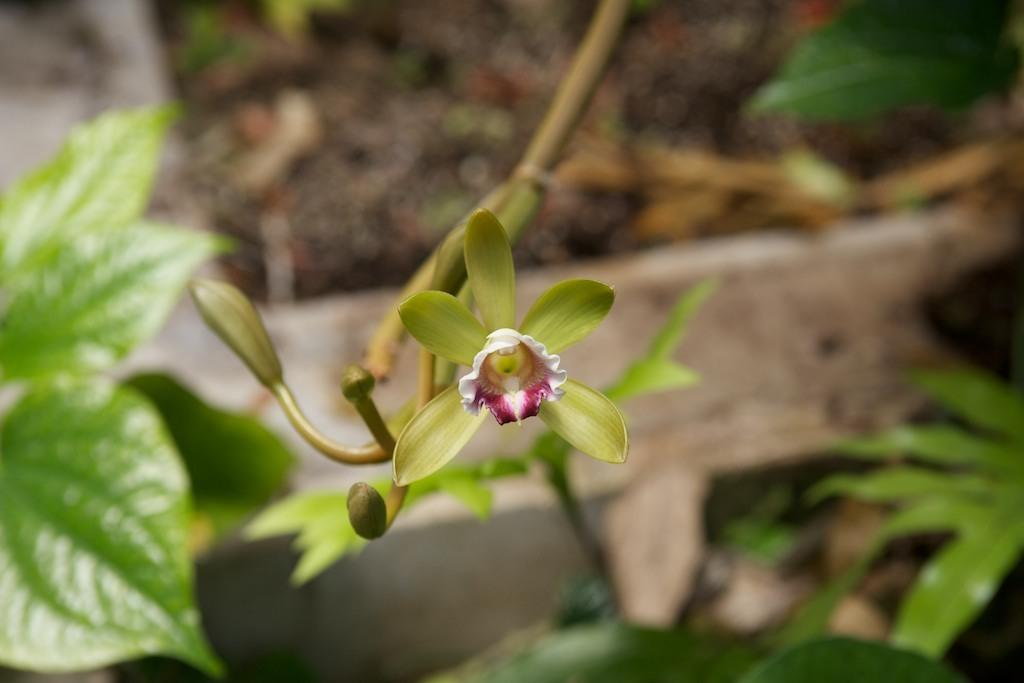What type of plant is visible in the image? There is a flower in the image. What else can be seen in the image besides the flower? There are leaves in the image. What type of creature is holding the map in the image? There is no creature or map present in the image; it only features a flower and leaves. 